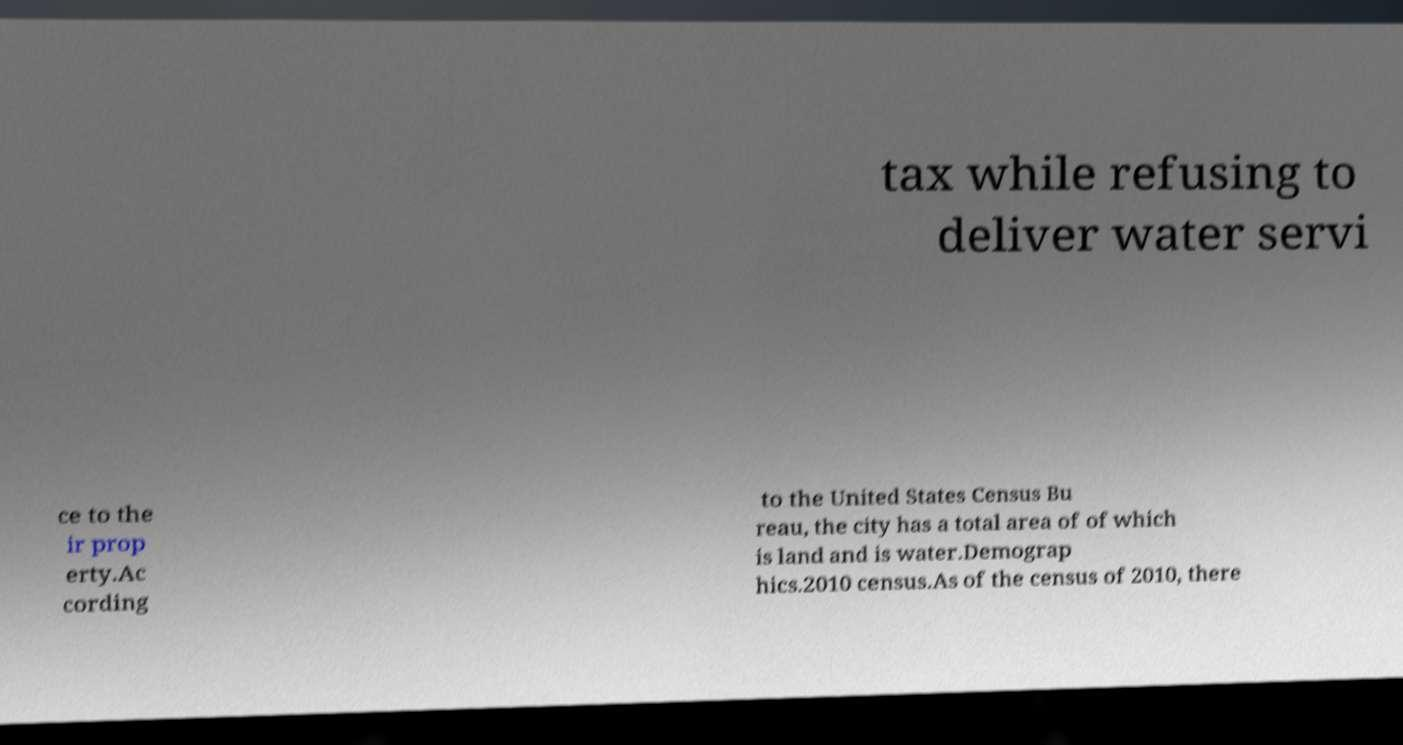There's text embedded in this image that I need extracted. Can you transcribe it verbatim? tax while refusing to deliver water servi ce to the ir prop erty.Ac cording to the United States Census Bu reau, the city has a total area of of which is land and is water.Demograp hics.2010 census.As of the census of 2010, there 